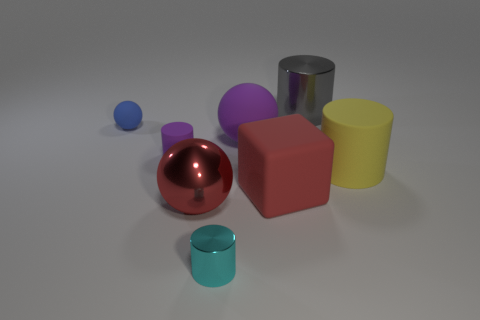What material is the tiny purple thing?
Your answer should be compact. Rubber. Is the shape of the gray thing the same as the blue rubber thing?
Your answer should be compact. No. Is there any other thing that has the same shape as the big red rubber thing?
Give a very brief answer. No. There is a rubber cylinder left of the cyan thing; is it the same color as the large matte object that is to the right of the red cube?
Ensure brevity in your answer.  No. Are there fewer small blue objects that are behind the gray shiny cylinder than large objects on the right side of the big red matte block?
Offer a very short reply. Yes. There is a shiny thing behind the red metallic thing; what is its shape?
Your answer should be very brief. Cylinder. There is a big sphere that is the same color as the large cube; what is its material?
Your answer should be compact. Metal. What number of other things are there of the same material as the large purple sphere
Offer a very short reply. 4. Does the blue thing have the same shape as the big metal object in front of the purple rubber cylinder?
Give a very brief answer. Yes. What shape is the small purple object that is the same material as the big yellow thing?
Offer a very short reply. Cylinder. 